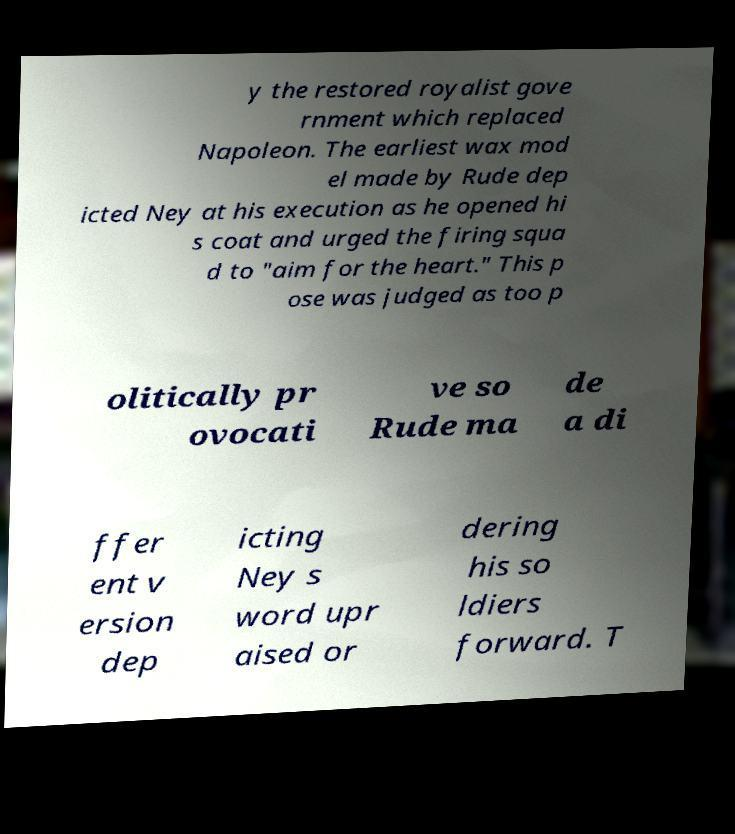What messages or text are displayed in this image? I need them in a readable, typed format. y the restored royalist gove rnment which replaced Napoleon. The earliest wax mod el made by Rude dep icted Ney at his execution as he opened hi s coat and urged the firing squa d to "aim for the heart." This p ose was judged as too p olitically pr ovocati ve so Rude ma de a di ffer ent v ersion dep icting Ney s word upr aised or dering his so ldiers forward. T 